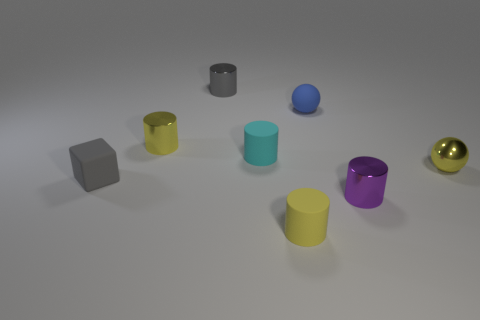What number of things are either metal cylinders that are in front of the small yellow shiny cylinder or tiny yellow cylinders to the left of the yellow rubber cylinder?
Offer a terse response. 2. Is there anything else that is the same shape as the tiny gray rubber object?
Your answer should be very brief. No. Is the color of the rubber cylinder in front of the small metal ball the same as the ball that is right of the blue matte object?
Your response must be concise. Yes. What number of rubber objects are small blue spheres or cyan cubes?
Your answer should be compact. 1. What is the shape of the tiny metallic object that is behind the tiny yellow cylinder left of the tiny cyan object?
Your answer should be compact. Cylinder. Is the material of the small gray thing that is behind the yellow metal cylinder the same as the small thing in front of the small purple thing?
Give a very brief answer. No. There is a yellow object that is right of the tiny yellow rubber thing; what number of yellow objects are behind it?
Offer a terse response. 1. Does the small yellow thing that is on the left side of the cyan object have the same shape as the small gray metal thing right of the small yellow metallic cylinder?
Your answer should be very brief. Yes. How big is the metallic thing that is in front of the gray shiny cylinder and on the left side of the tiny purple shiny object?
Make the answer very short. Small. There is another object that is the same shape as the blue rubber thing; what color is it?
Your response must be concise. Yellow. 